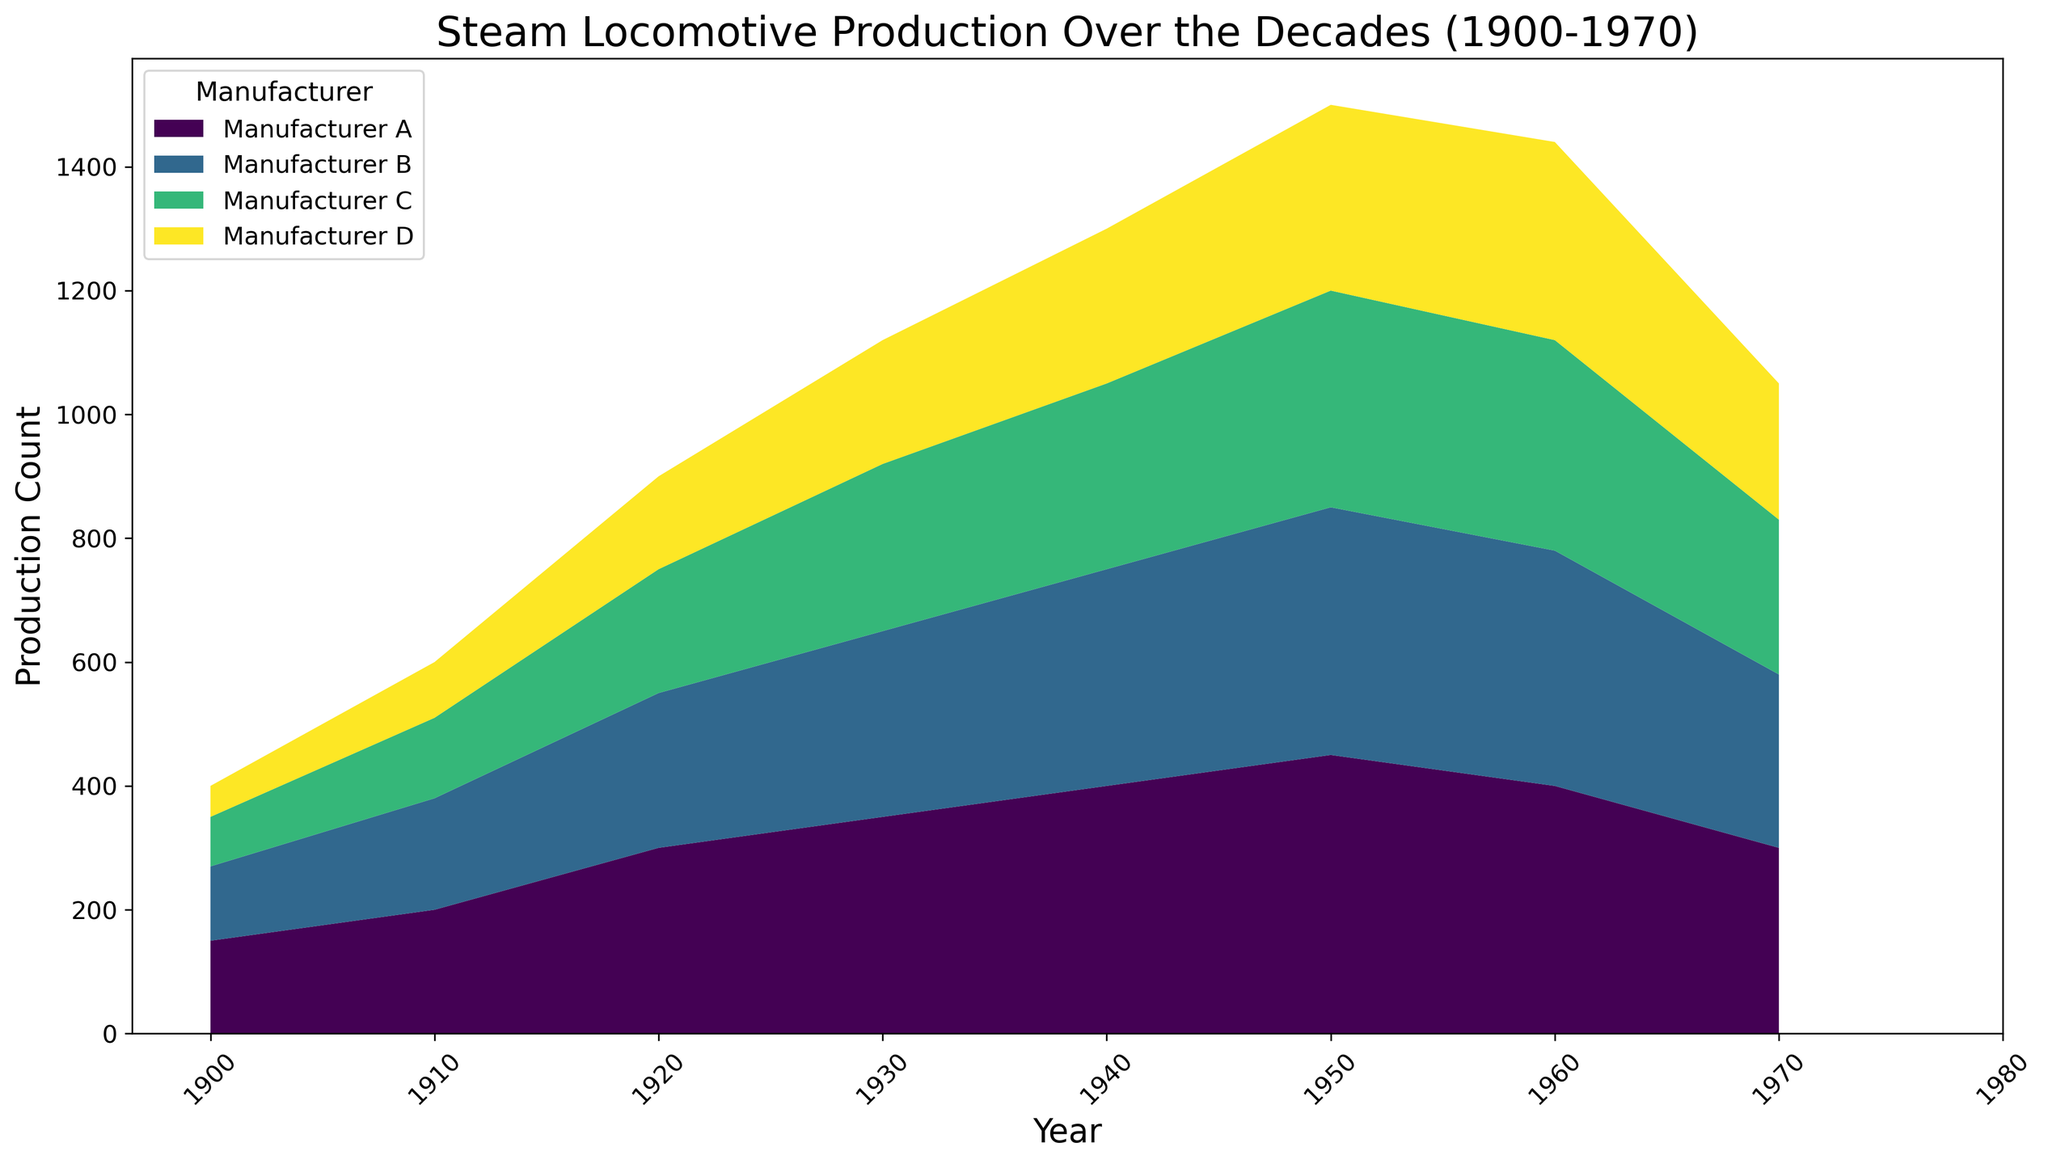Which manufacturer had the highest production count in 1950? To find the manufacturer with the highest production count in 1950, look at the topmost segment of the area chart for that year. The highest point represents Manufacturer A.
Answer: Manufacturer A Compare the production counts of Manufacturer A and Manufacturer D in 1930. Which manufacturer had a higher count and by how much? Identify the segments for Manufacturer A and Manufacturer D in 1930. Manufacturer A had more production than Manufacturer D. Manufacturer A produced 350 units, and Manufacturer D produced 200 units. The difference is 350 - 200 = 150 units.
Answer: Manufacturer A by 150 units How did steam locomotive production change for Manufacturer B from 1940 to 1970? Look at the change in height of the segment representing Manufacturer B between 1940 and 1970. In 1940, the height for Manufacturer B is high and then gradually decreases through 1970. The production count goes from 350 to 280.
Answer: Decreased What year saw the highest combined production count for all manufacturers? Identify the year where the overall height of the stack plot is the tallest. 1950 stands out as the year with the highest combined production count.
Answer: 1950 By how much did the production count of Manufacturer C increase or decrease from 1910 to 1920? Compare the height of Manufacturer C's segment in 1910 and 1920. In 1910, it was 130, and in 1920, it was 200. The increase is 200 - 130 = 70 units.
Answer: Increased by 70 units Which manufacturer experienced the steepest decline in production between any two decades? Look at the segments showing the steepest decline between any two consecutive decades. Manufacturer A from 1960 to 1970 shows a steep decline from 400 to 300, losing 100 units.
Answer: Manufacturer A What was the total production count for all manufacturers in 1940? Sum the production counts of all manufacturers in 1940: 400 (A) + 350 (B) + 300 (C) + 250 (D). Total is 400 + 350 + 300 + 250 = 1300 units.
Answer: 1300 units Between Manufacturer B and Manufacturer C, which one had more consistent production counts over the decades? Look for the segments of Manufacturer B and C for clear ups and downs. Manufacturer B shows less fluctuation compared to Manufacturer C.
Answer: Manufacturer B What's the relative change in production count for Manufacturer D from 1930 to 1940? Calculate the percent change for Manufacturer D from 1930 to 1940. In 1930, the count was 200; in 1940, it was 250. The change is (250 - 200) / 200 * 100 = 25%.
Answer: Increased by 25% 